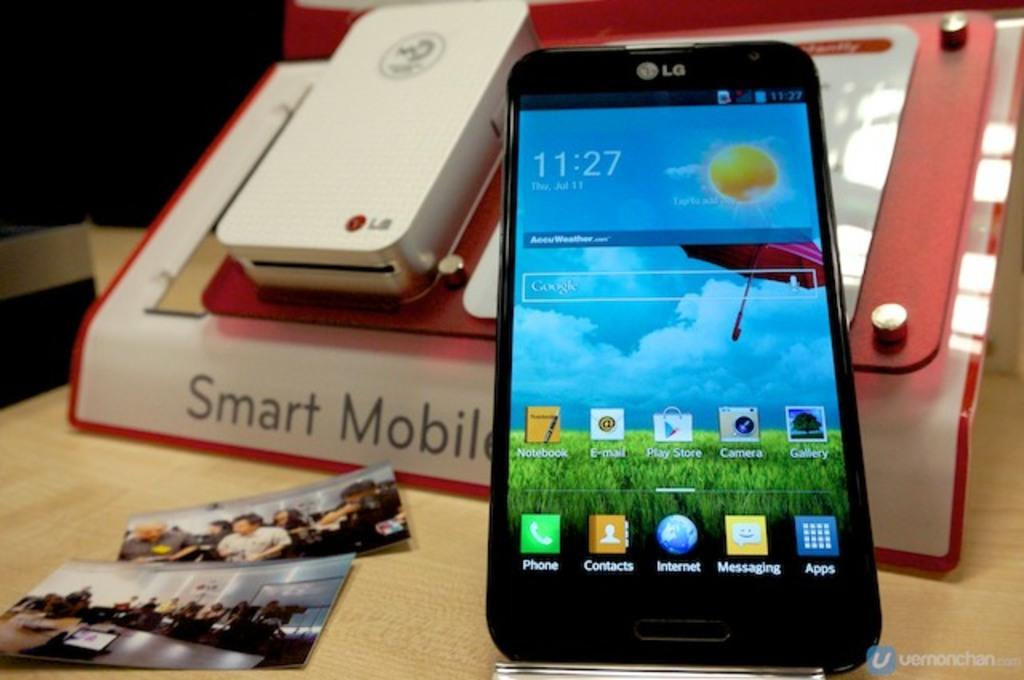<image>
Relay a brief, clear account of the picture shown. An LG phone displays a time of 11:27. 